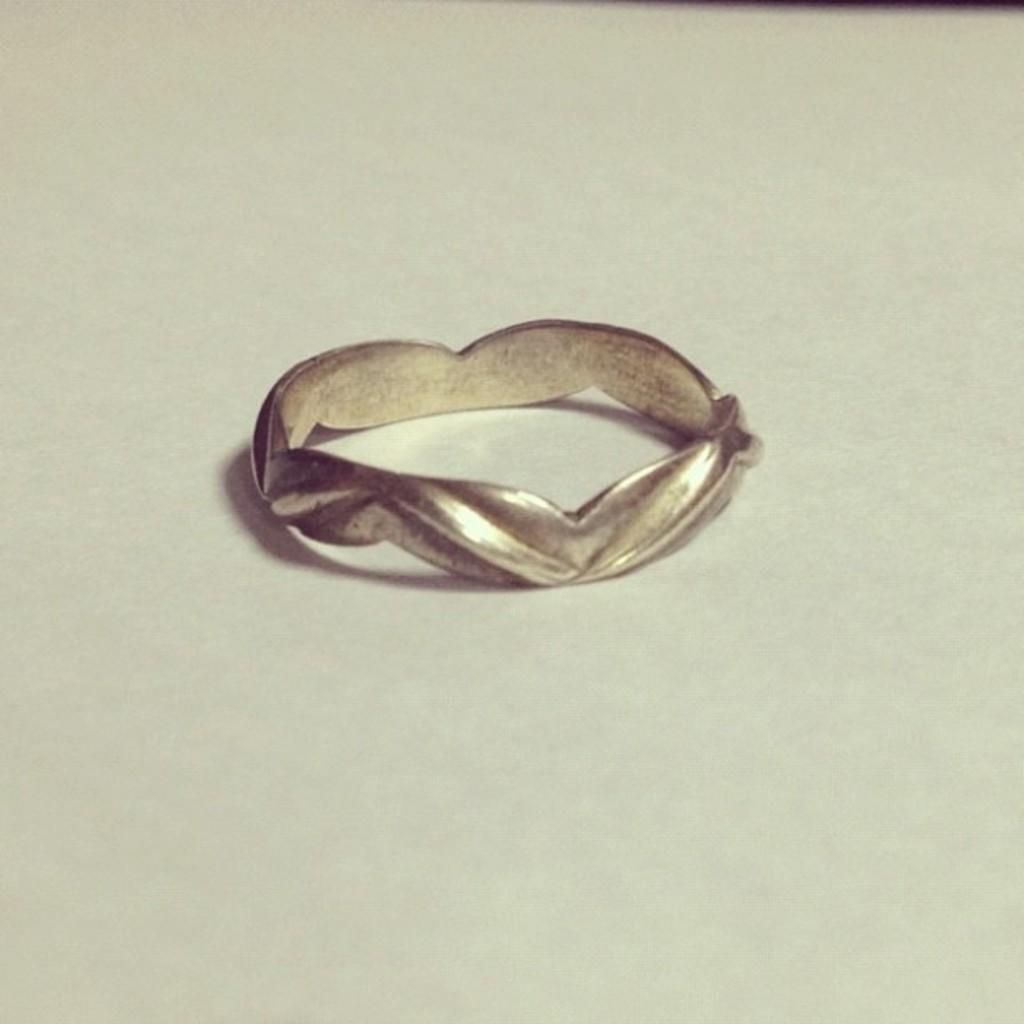What is the main subject of the image? The main subject of the image is a ring. Where is the ring located in the image? The ring is in the center of the image. What color is the surface beneath the ring? The surface beneath the ring is white in color. What type of polish is being applied to the ring in the image? There is no indication in the image that any polish is being applied to the ring. Can you see any sails in the image? There are no sails present in the image. 